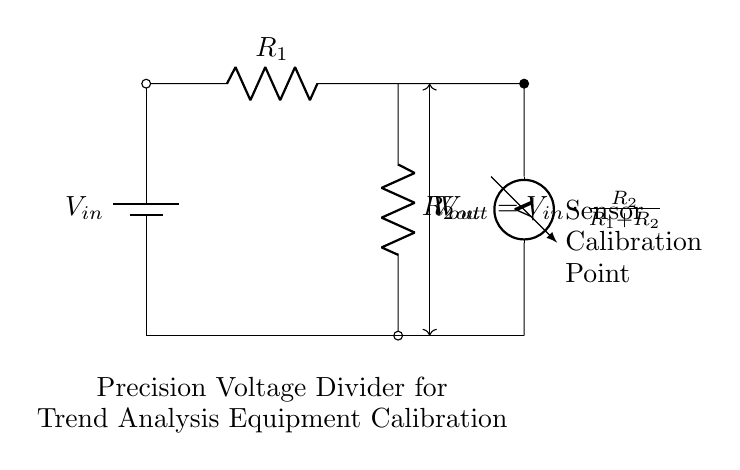What is the input voltage of the circuit? The input voltage, denoted as V_in, is the voltage supplied to the circuit at the leftmost point labeled in the diagram.
Answer: V_in What are the resistor values used in the circuit? The circuit diagram labels two resistors, R_1 and R_2, but does not specify numerical values. Therefore, the values remain undefined in this context.
Answer: Undefined What is the output voltage formula in this circuit? The output voltage, V_out, is calculated using the voltage divider formula provided in the circuit: V_out = V_in * (R_2 / (R_1 + R_2)). This relation describes how the input voltage is divided between the resistors.
Answer: V_out = V_in * (R_2 / (R_1 + R_2)) How does changing R_2 affect V_out? Increasing R_2 increases the proportion of V_in that appears across R_2, thus increasing V_out, while decreasing R_2 decreases V_out. This is deduced from the voltage divider principle.
Answer: V_out increases with R_2 What function does the sensor serve in this circuit? The sensor is mentioned in the diagram as being at the output point; it indicates that the output voltage is being used to calibrate or measure the sensor's performance under certain conditions.
Answer: Calibration What does the voltmeter measure in this circuit? The voltmeter is connected across R_2, allowing it to measure the voltage across this resistor, which serves as the output voltage V_out for calibration purposes.
Answer: V_out 